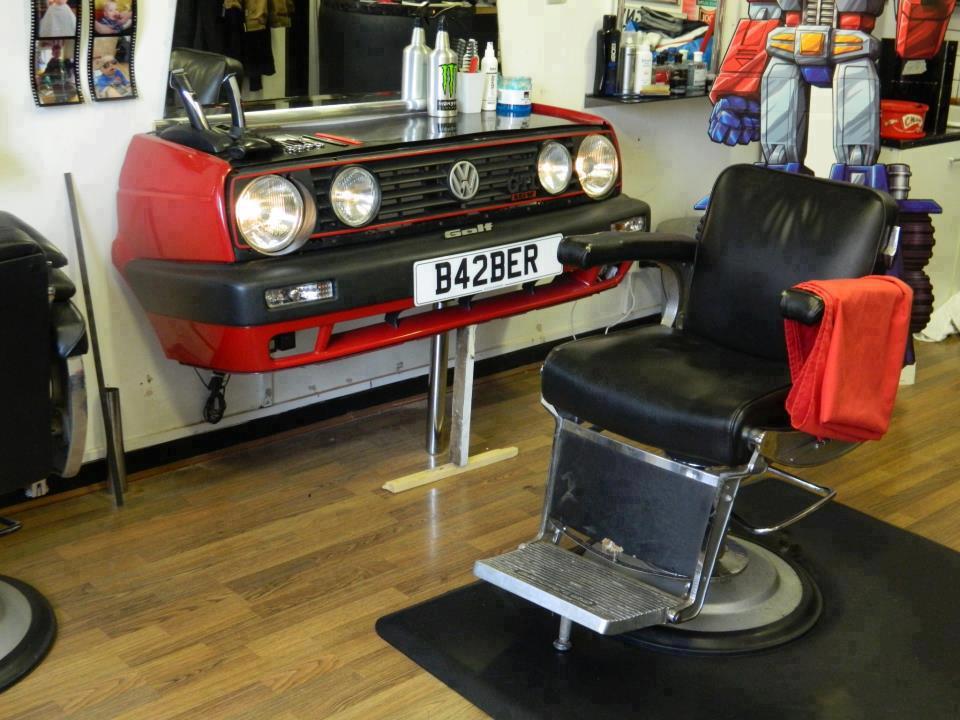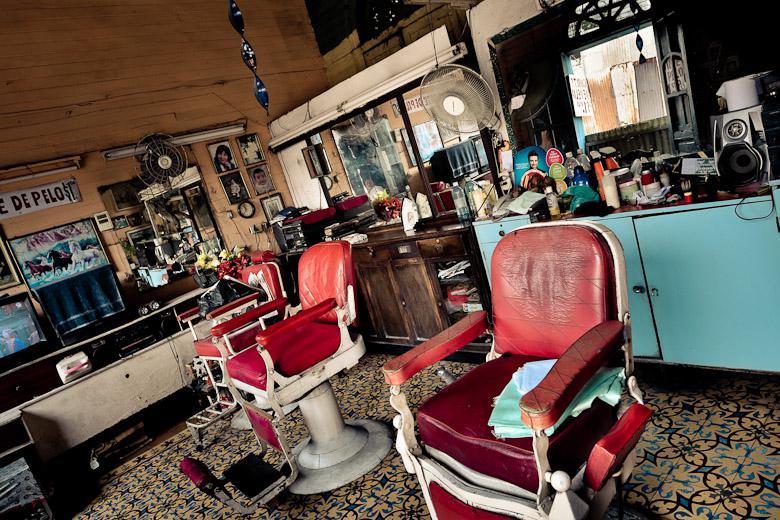The first image is the image on the left, the second image is the image on the right. Given the left and right images, does the statement "There is a barber pole in the image on the left." hold true? Answer yes or no. No. 